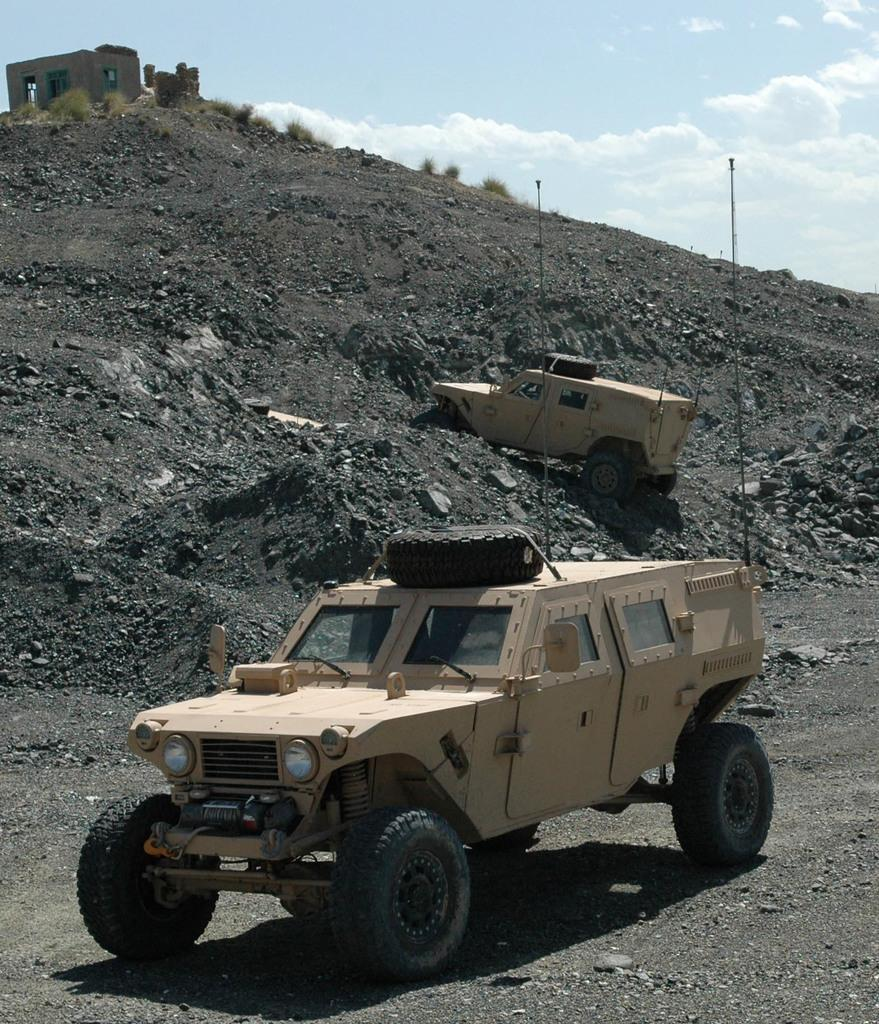What type of objects can be seen in the image? There are vehicles in the image. What color are the vehicles? The vehicles are cream-colored. What can be seen in the background of the image? There are plants and a house in the background of the image. What color are the plants? The plants are green. What is the color of the sky in the image? The sky is white in color. Can you see any jars of jam on the vehicles in the image? There are no jars of jam present in the image. Are there any deer visible in the background of the image? There are no deer present in the image. 